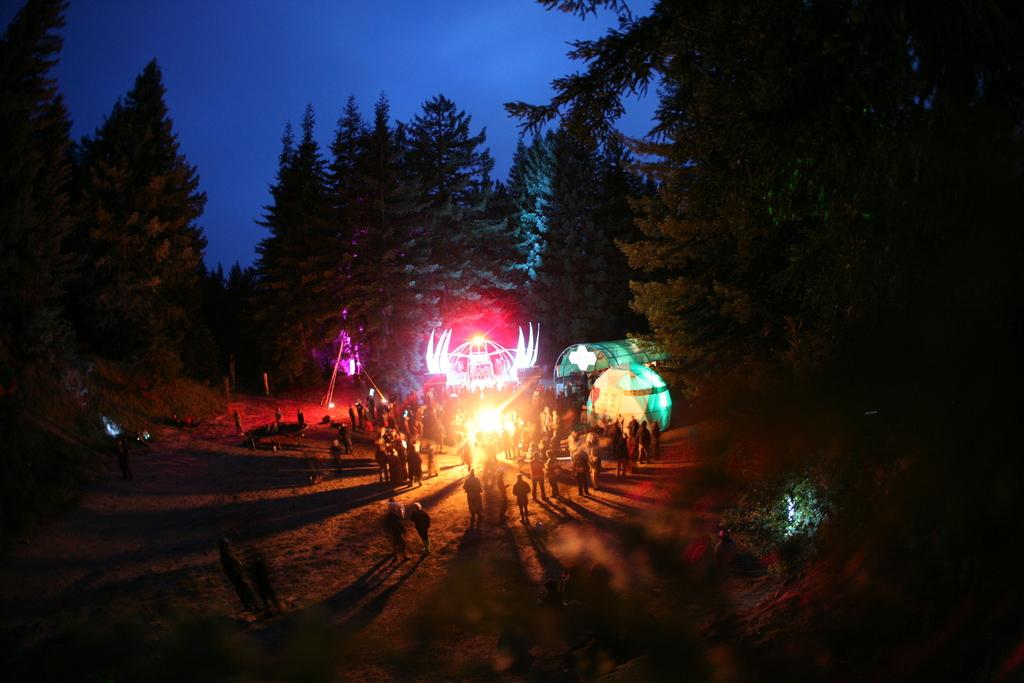What is happening in the image involving the group of people? The group of men and women is enjoying a party. What can be seen in the shed in the image? There are red and green color spots lights in the shed. What is visible in the background of the image? Huge trees are visible in the background of the image. How many crows are perched on the branch in the image? There are no crows or branches present in the image. What time of day is the party taking place? The provided facts do not mention the time of day, so it cannot be determined from the image. 